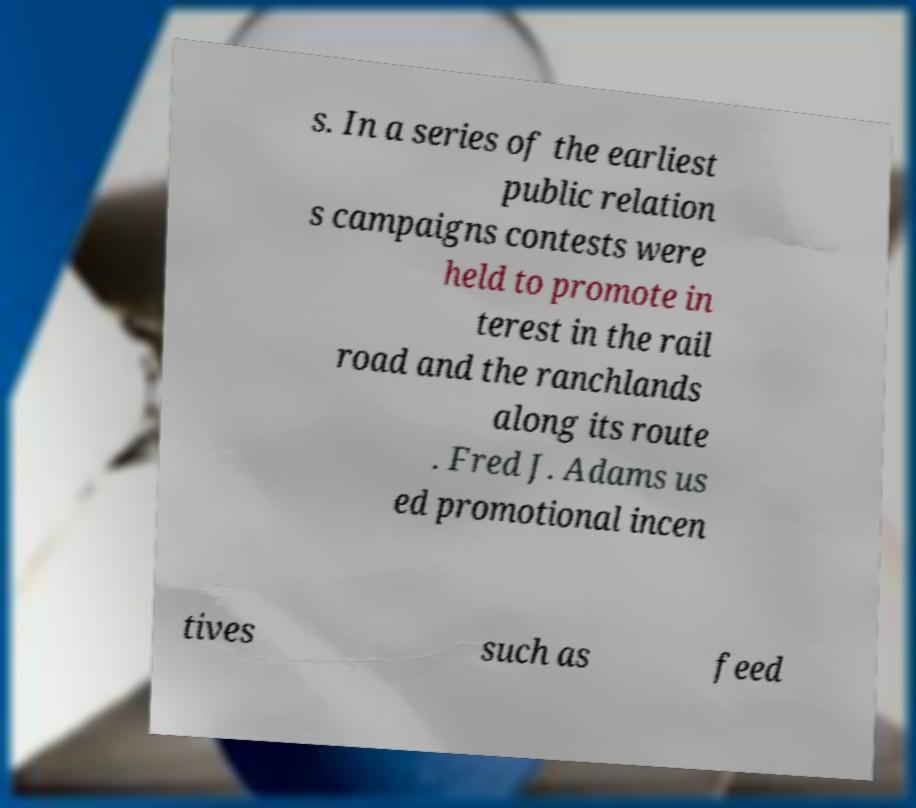Could you assist in decoding the text presented in this image and type it out clearly? s. In a series of the earliest public relation s campaigns contests were held to promote in terest in the rail road and the ranchlands along its route . Fred J. Adams us ed promotional incen tives such as feed 